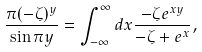Convert formula to latex. <formula><loc_0><loc_0><loc_500><loc_500>\frac { \pi ( - \zeta ) ^ { y } } { \sin \pi y } = \int _ { - \infty } ^ { \infty } d x \frac { - \zeta e ^ { x y } } { - \zeta + e ^ { x } } ,</formula> 